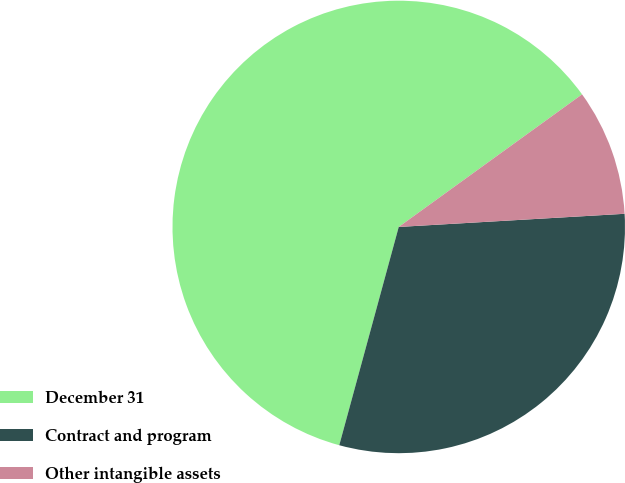<chart> <loc_0><loc_0><loc_500><loc_500><pie_chart><fcel>December 31<fcel>Contract and program<fcel>Other intangible assets<nl><fcel>60.8%<fcel>30.16%<fcel>9.04%<nl></chart> 